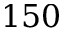Convert formula to latex. <formula><loc_0><loc_0><loc_500><loc_500>1 5 0</formula> 